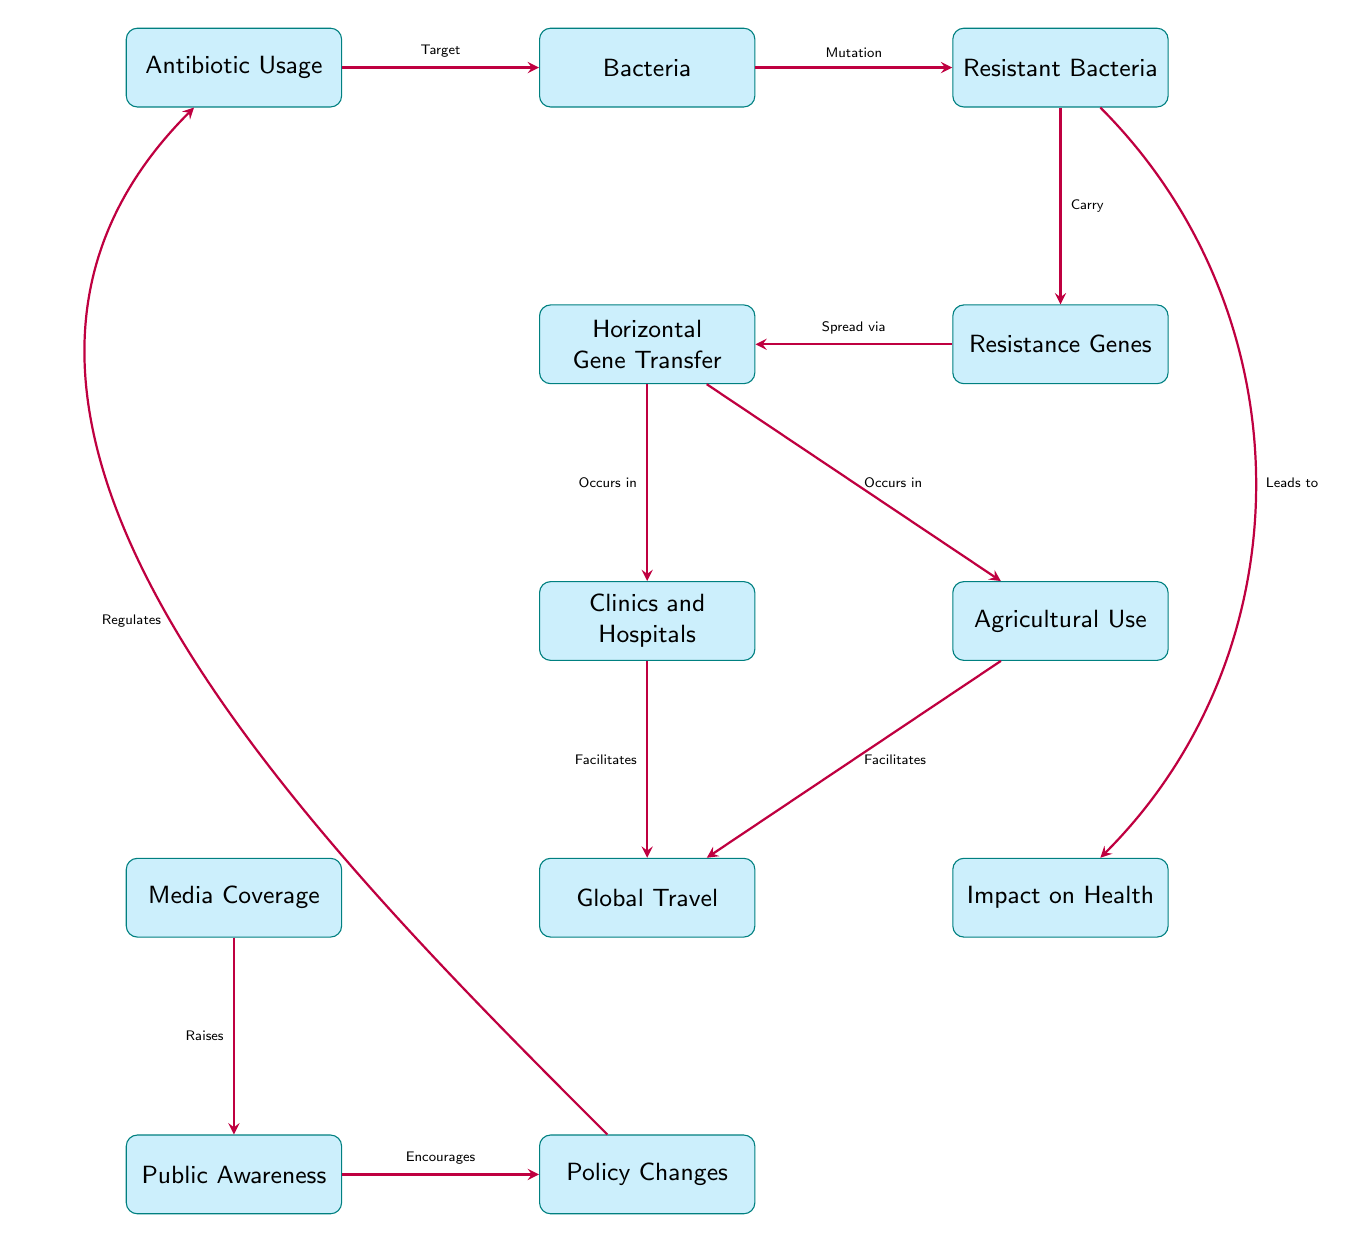What is the first node in the diagram? The first node listed in the diagram is "Antibiotic Usage", which is the entry point of the flow showing how antibiotics affect bacteria.
Answer: Antibiotic Usage Which node indicates the transfer of resistance genes? The node that indicates the transfer of resistance genes is "Horizontal Gene Transfer", which is responsible for spreading the genes among bacteria.
Answer: Horizontal Gene Transfer What role does media coverage play in public awareness? Media coverage is indicated in the diagram to raise public awareness, serving as a conduit for information about antibiotic resistance.
Answer: Raises How many pathways lead from the "Resistant Bacteria" node? There are two pathways leading from the "Resistant Bacteria" node: one leading directly to "Impact on Health" and the other leading to "Resistance Genes".
Answer: 2 What does "Global Travel" facilitate according to the diagram? According to the diagram, "Global Travel" facilitates the spread of resistant bacteria from clinics and agriculture to different regions.
Answer: Spread of resistant bacteria What results from increased public awareness according to the diagram? Increased public awareness encourages policy changes, which are designed to regulate antibiotic usage and combat resistance.
Answer: Encourages policy Which two contexts are mentioned in the diagram where horizontal gene transfer occurs? The two contexts where horizontal gene transfer occurs are "Clinics and Hospitals" and "Agricultural Use".
Answer: Clinics and Hospitals, Agricultural Use What effect does antibiotic usage have on bacteria? The effect of antibiotic usage on bacteria is that it targets them, potentially leading to mutations that create resistant strains.
Answer: Target Why is the relationship between "Awareness" and "Policy Changes" significant in the context of public health? The relationship is significant because awareness leads to policy changes that can regulate antibiotic use, which is crucial in managing and mitigating antibiotic resistance issues.
Answer: Regulates 